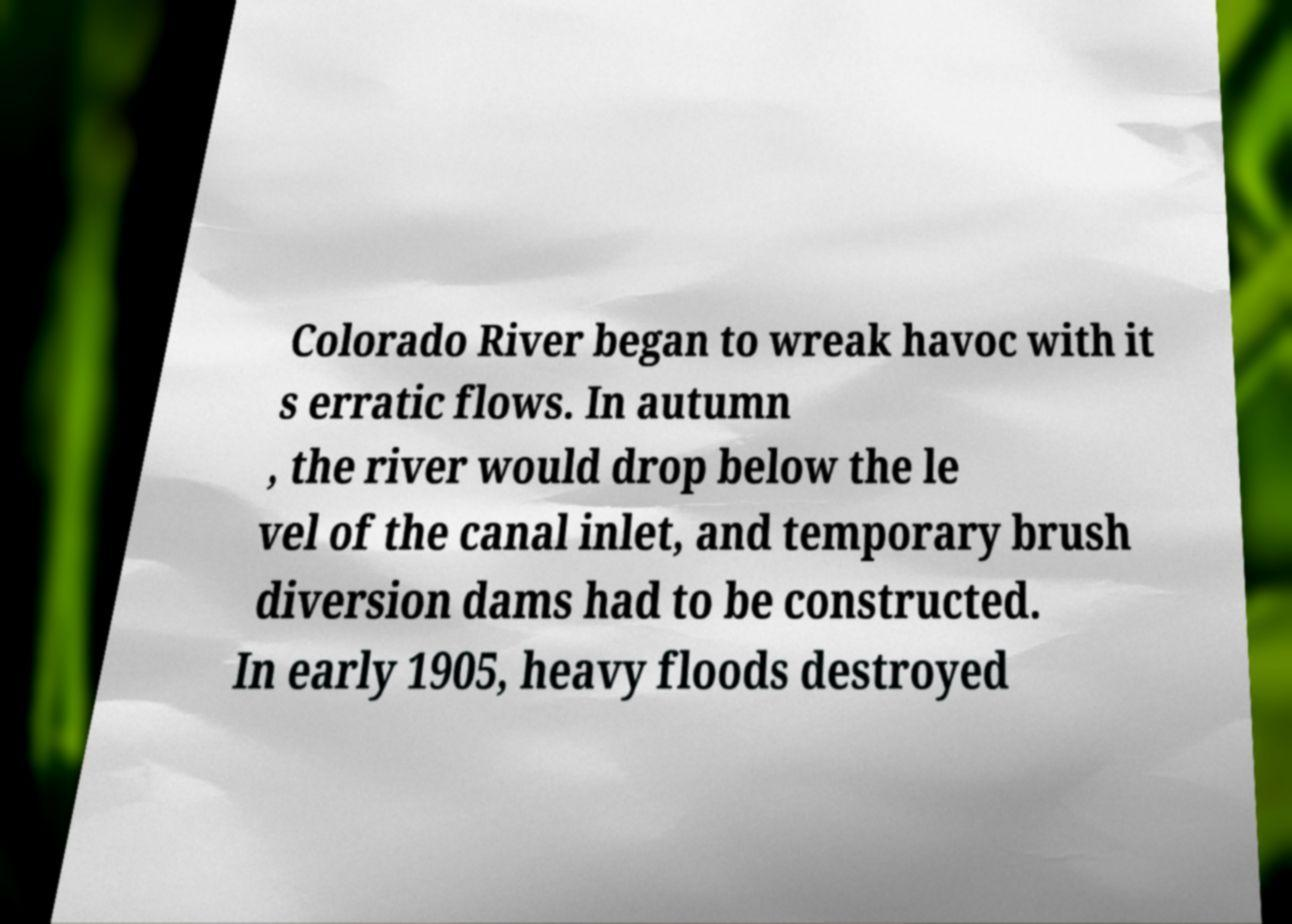I need the written content from this picture converted into text. Can you do that? Colorado River began to wreak havoc with it s erratic flows. In autumn , the river would drop below the le vel of the canal inlet, and temporary brush diversion dams had to be constructed. In early 1905, heavy floods destroyed 